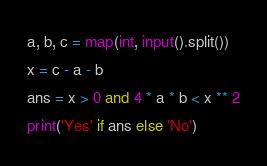Convert code to text. <code><loc_0><loc_0><loc_500><loc_500><_Python_>a, b, c = map(int, input().split())
x = c - a - b
ans = x > 0 and 4 * a * b < x ** 2
print('Yes' if ans else 'No')</code> 